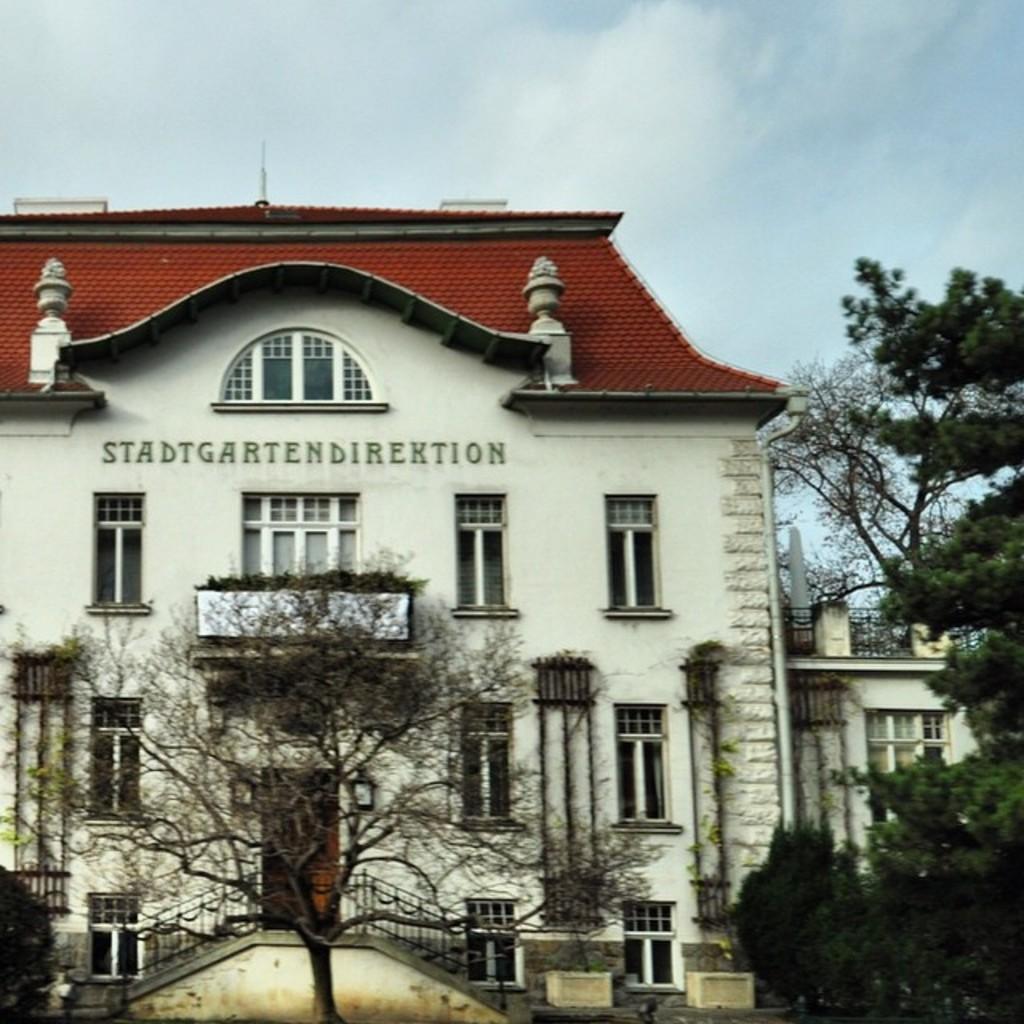Please provide a concise description of this image. In this picture I can observe building in the middle of the picture. In front of the building I can observe trees. In the background there are some clouds in the sky. 